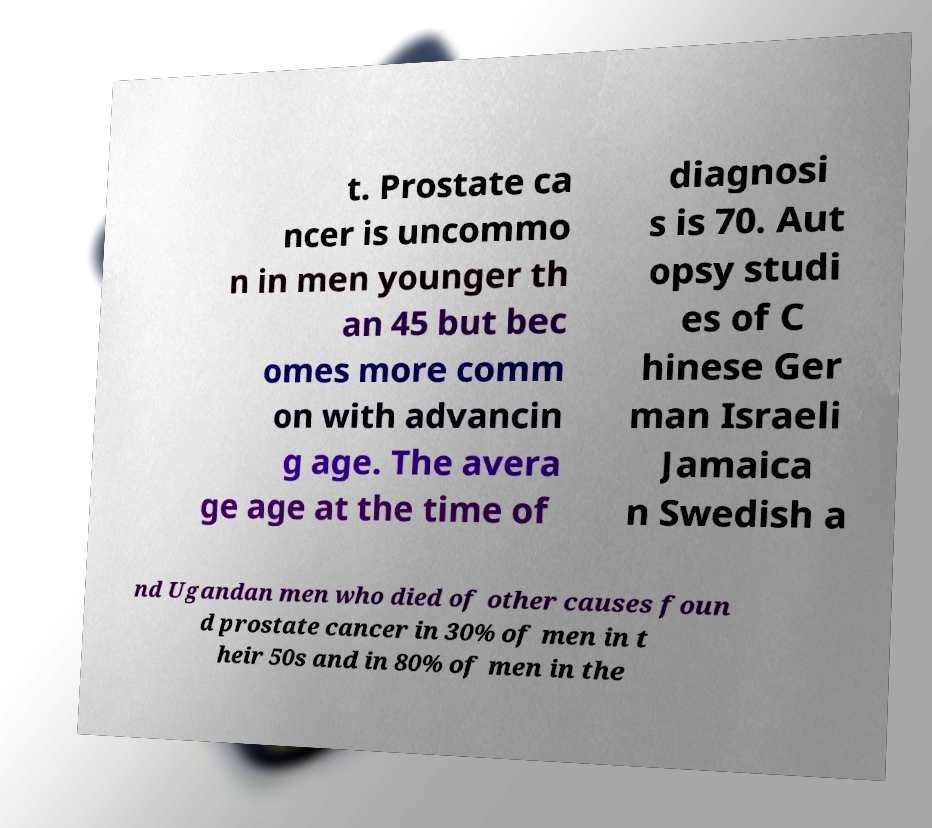Can you read and provide the text displayed in the image?This photo seems to have some interesting text. Can you extract and type it out for me? t. Prostate ca ncer is uncommo n in men younger th an 45 but bec omes more comm on with advancin g age. The avera ge age at the time of diagnosi s is 70. Aut opsy studi es of C hinese Ger man Israeli Jamaica n Swedish a nd Ugandan men who died of other causes foun d prostate cancer in 30% of men in t heir 50s and in 80% of men in the 